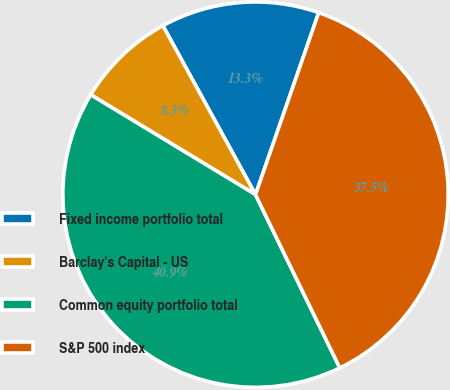<chart> <loc_0><loc_0><loc_500><loc_500><pie_chart><fcel>Fixed income portfolio total<fcel>Barclay's Capital - US<fcel>Common equity portfolio total<fcel>S&P 500 index<nl><fcel>13.3%<fcel>8.35%<fcel>40.88%<fcel>37.48%<nl></chart> 